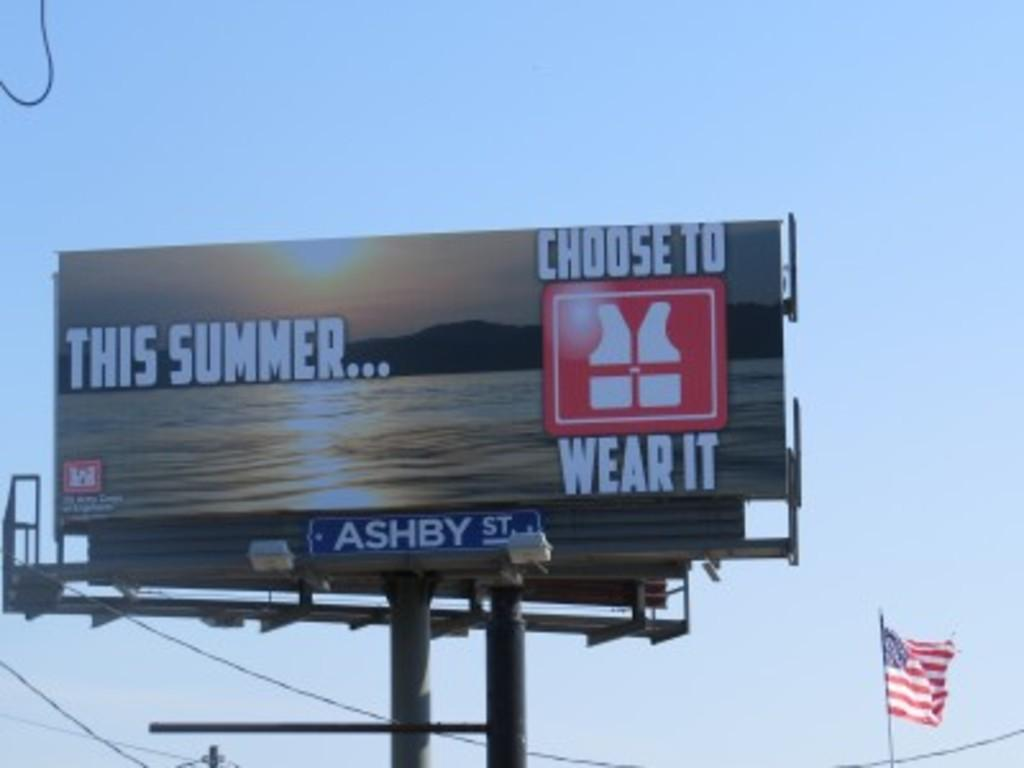<image>
Describe the image concisely. A billboard is advertising wearing a life jacket this summer. 